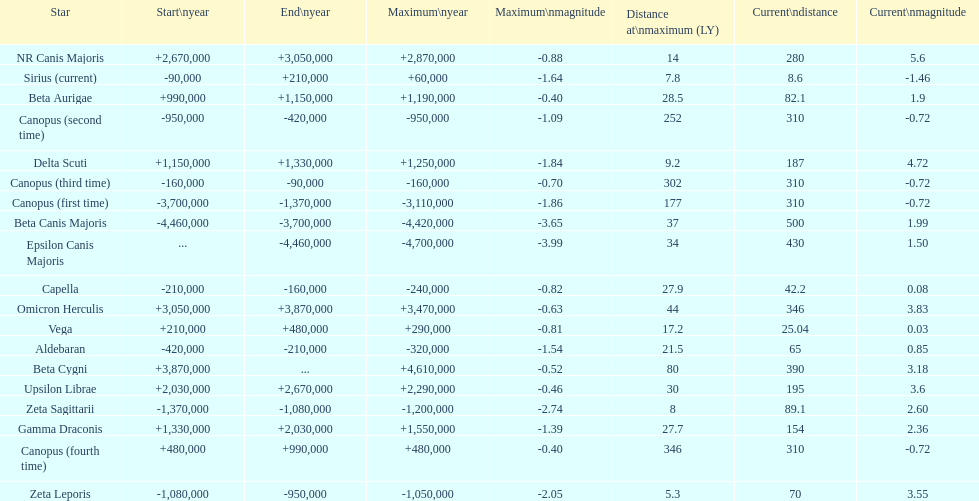How much farther (in ly) is epsilon canis majoris than zeta sagittarii? 26. 